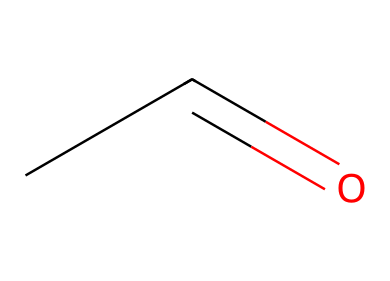What is the molecular formula of the chemical represented? The SMILES representation "CC=O" indicates that there are two carbon atoms (C), four hydrogen atoms (H), and one oxygen atom (O) present in the structure. Thus, the molecular formula can be derived by counting the individual atoms in the structure.
Answer: C2H4O How many carbon atoms are in this chemical? By examining the SMILES representation "CC=O", it is clear that there are two carbon atoms present (the "CC" part indicates two carbon atoms).
Answer: 2 What type of functional group is present in this compound? The SMILES "CC=O" shows that there is a carbon (C) double-bonded to an oxygen (O), which is characteristic of an aldehyde functional group. The presence of a carbonyl group (C=O) at the end of a carbon chain identifies it as an aldehyde.
Answer: aldehyde What is the saturation level of this molecule? The presence of a double bond in the "CC=O" structure indicates that the molecule is unsaturated. A fully saturated molecule would only have single bonds. Therefore, we recognize that the double bond means it has a lower hydrogen count relative to the maximum possible for its carbon atoms.
Answer: unsaturated How many hydrogen atoms are attached to each carbon in acetaldehyde? In the structure "CC=O", the first carbon (attached to the carbonyl group) has three hydrogen atoms (making it CH3), while the second carbon (the one next to the carbonyl) has one hydrogen atom (making it CH). Therefore, each carbon has different hydrogen counts.
Answer: 3 and 1 What is the primary source of acetaldehyde in humans? Acetaldehyde is primarily produced in the human body during the metabolism of ethanol (alcohol). After ingesting alcohol, the liver processes it and converts it into acetaldehyde via the action of enzymes, making this byproduct a direct result of alcohol consumption.
Answer: ethanol metabolism 